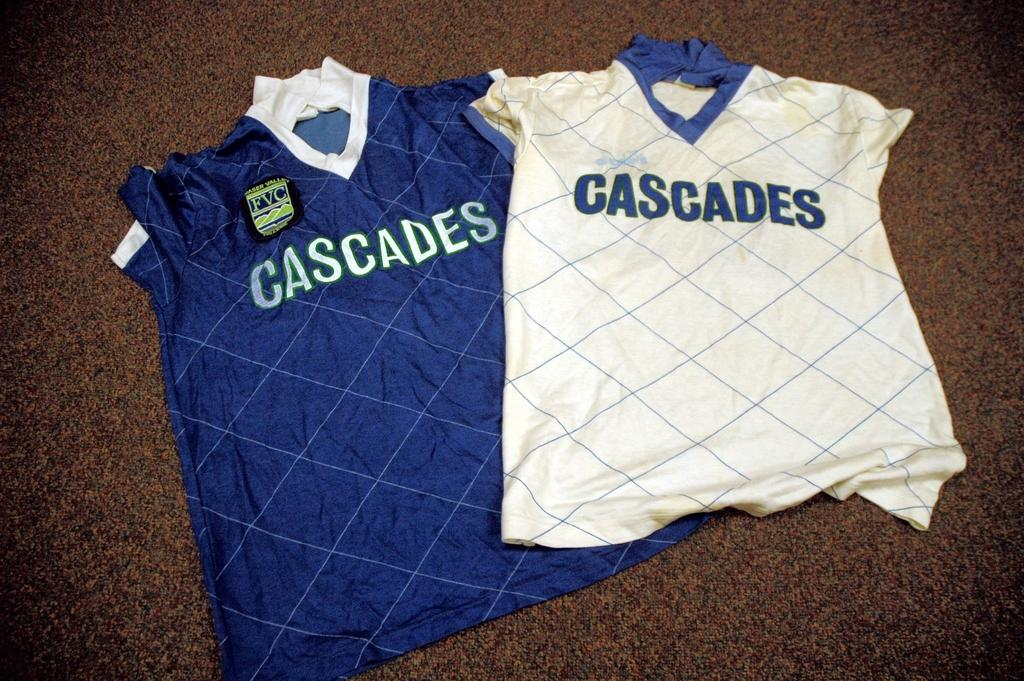<image>
Render a clear and concise summary of the photo. A white and blue shirt that say Cascades are on the floor next to each other. 